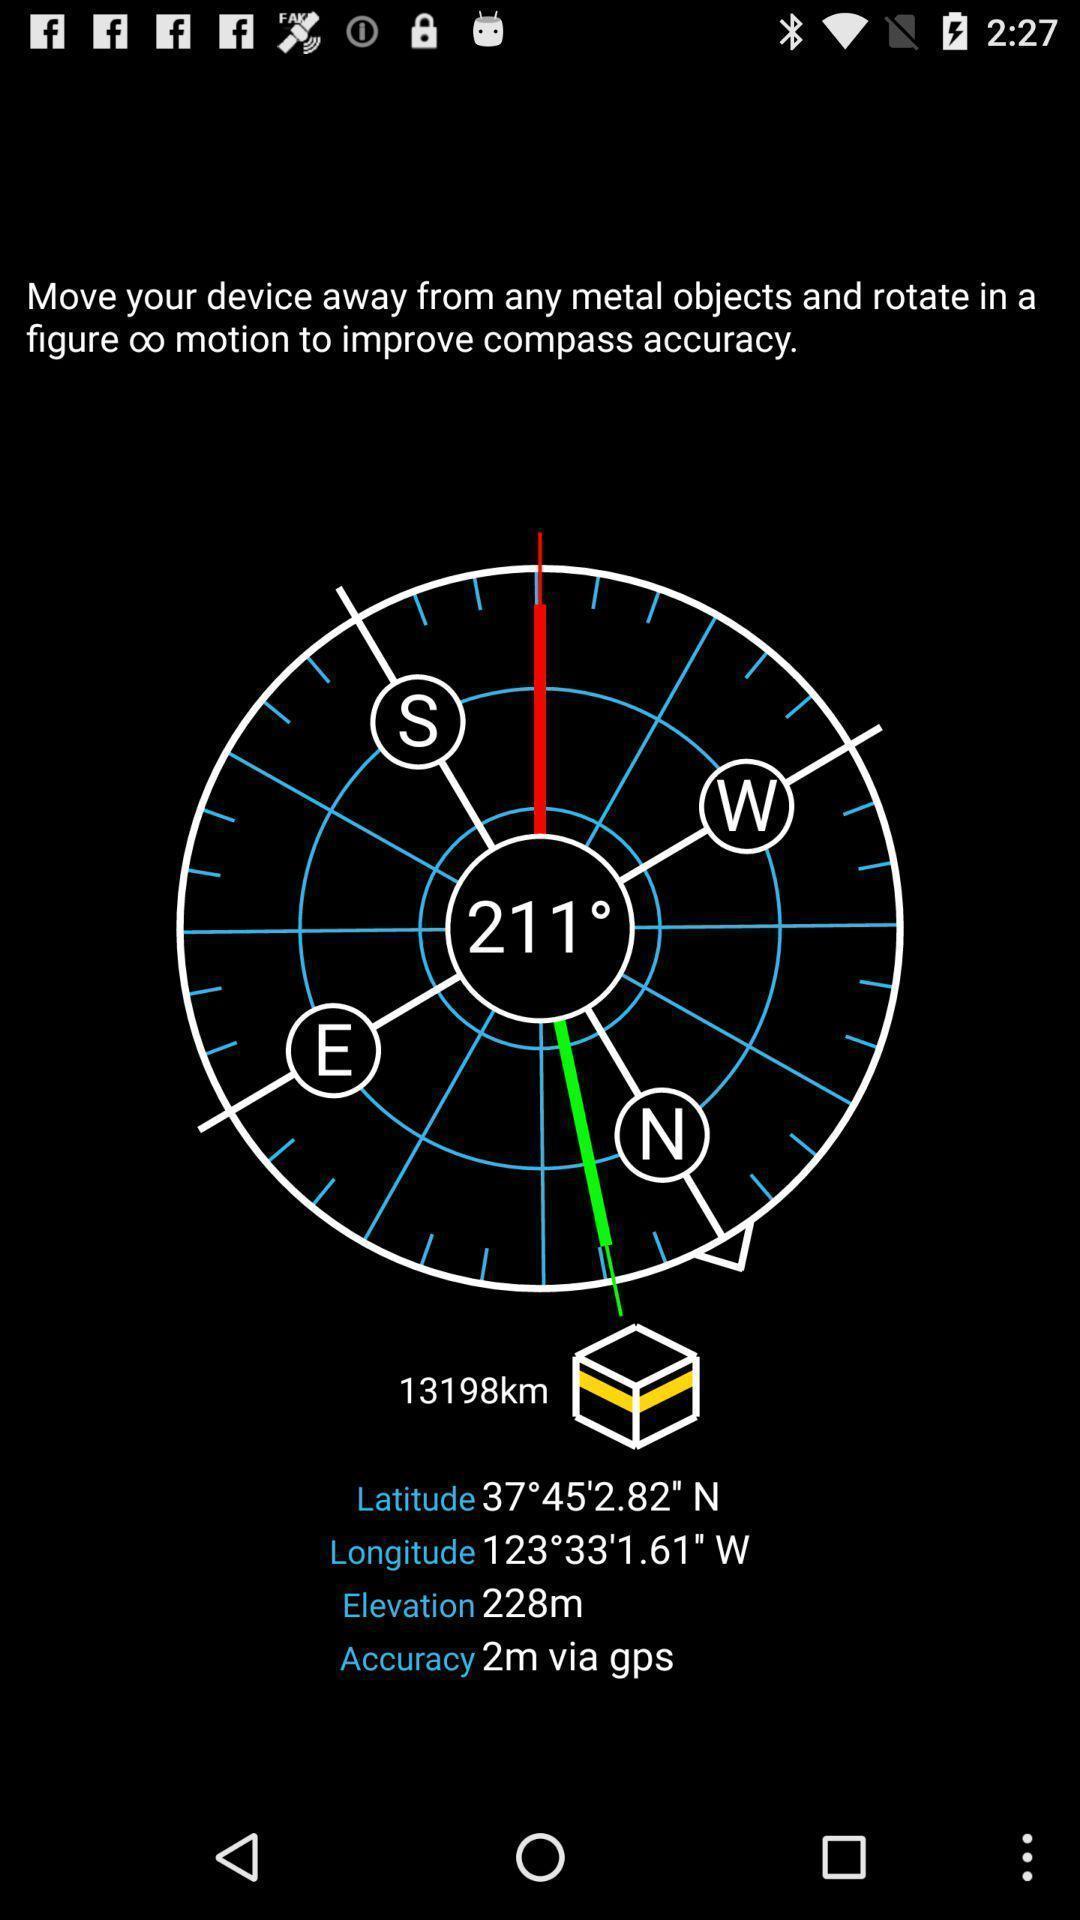Give me a narrative description of this picture. Welcome page displaying description. 